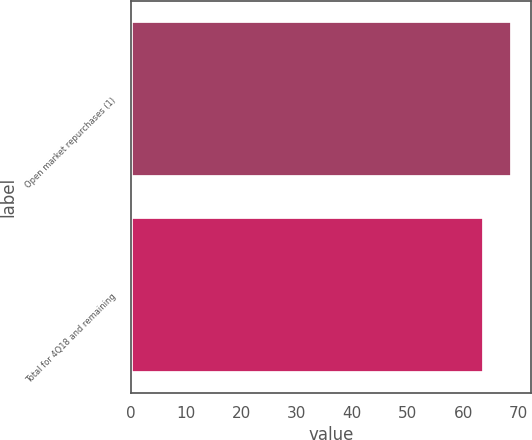Convert chart to OTSL. <chart><loc_0><loc_0><loc_500><loc_500><bar_chart><fcel>Open market repurchases (1)<fcel>Total for 4Q18 and remaining<nl><fcel>68.78<fcel>63.7<nl></chart> 